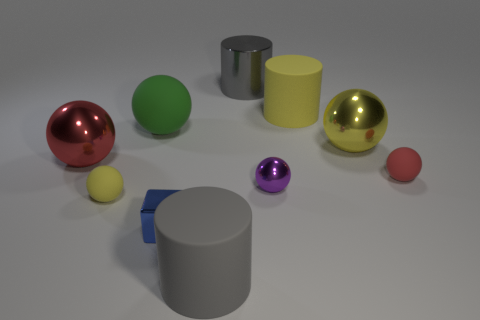How would you analyze the colors used in the composition? The composition features a selective color palette with primary colors like red, yellow, and blue, as well as secondary colors like green and purple. These colors are used in a way that creates a pleasing contrast, and the gray and white background provides a neutral base that accentuates the vibrancy of the colored objects. 